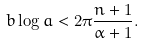<formula> <loc_0><loc_0><loc_500><loc_500>b \log a < 2 \pi \frac { n + 1 } { \alpha + 1 } .</formula> 